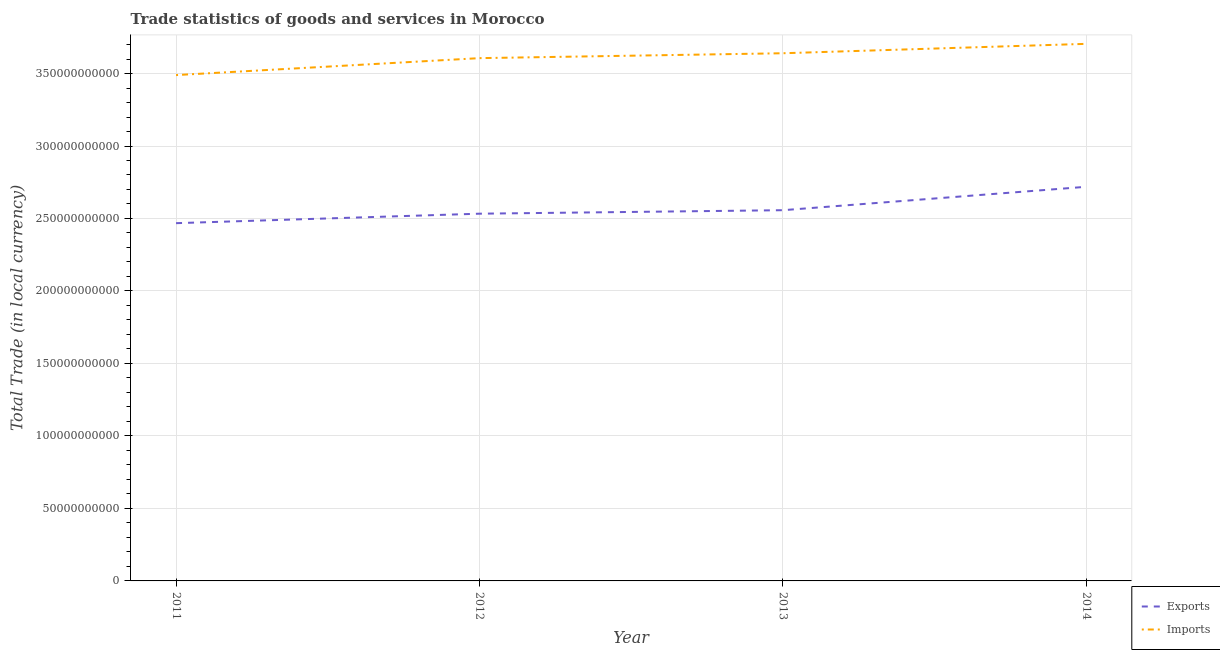How many different coloured lines are there?
Your response must be concise. 2. Does the line corresponding to imports of goods and services intersect with the line corresponding to export of goods and services?
Your answer should be very brief. No. What is the export of goods and services in 2014?
Provide a short and direct response. 2.72e+11. Across all years, what is the maximum imports of goods and services?
Your answer should be compact. 3.70e+11. Across all years, what is the minimum imports of goods and services?
Ensure brevity in your answer.  3.49e+11. What is the total export of goods and services in the graph?
Your answer should be very brief. 1.03e+12. What is the difference between the imports of goods and services in 2011 and that in 2012?
Your answer should be compact. -1.17e+1. What is the difference between the imports of goods and services in 2011 and the export of goods and services in 2014?
Make the answer very short. 7.71e+1. What is the average imports of goods and services per year?
Your answer should be very brief. 3.61e+11. In the year 2013, what is the difference between the export of goods and services and imports of goods and services?
Provide a succinct answer. -1.08e+11. What is the ratio of the export of goods and services in 2011 to that in 2014?
Your answer should be compact. 0.91. Is the imports of goods and services in 2012 less than that in 2013?
Your answer should be very brief. Yes. Is the difference between the imports of goods and services in 2012 and 2013 greater than the difference between the export of goods and services in 2012 and 2013?
Provide a short and direct response. No. What is the difference between the highest and the second highest imports of goods and services?
Provide a short and direct response. 6.49e+09. What is the difference between the highest and the lowest imports of goods and services?
Provide a short and direct response. 2.15e+1. Is the imports of goods and services strictly less than the export of goods and services over the years?
Your answer should be very brief. No. How many lines are there?
Provide a succinct answer. 2. Are the values on the major ticks of Y-axis written in scientific E-notation?
Give a very brief answer. No. Does the graph contain any zero values?
Give a very brief answer. No. Does the graph contain grids?
Give a very brief answer. Yes. How many legend labels are there?
Give a very brief answer. 2. What is the title of the graph?
Your answer should be very brief. Trade statistics of goods and services in Morocco. What is the label or title of the X-axis?
Give a very brief answer. Year. What is the label or title of the Y-axis?
Your response must be concise. Total Trade (in local currency). What is the Total Trade (in local currency) in Exports in 2011?
Give a very brief answer. 2.47e+11. What is the Total Trade (in local currency) of Imports in 2011?
Keep it short and to the point. 3.49e+11. What is the Total Trade (in local currency) of Exports in 2012?
Offer a very short reply. 2.53e+11. What is the Total Trade (in local currency) in Imports in 2012?
Ensure brevity in your answer.  3.61e+11. What is the Total Trade (in local currency) of Exports in 2013?
Make the answer very short. 2.56e+11. What is the Total Trade (in local currency) of Imports in 2013?
Provide a succinct answer. 3.64e+11. What is the Total Trade (in local currency) of Exports in 2014?
Your answer should be compact. 2.72e+11. What is the Total Trade (in local currency) in Imports in 2014?
Provide a short and direct response. 3.70e+11. Across all years, what is the maximum Total Trade (in local currency) of Exports?
Offer a very short reply. 2.72e+11. Across all years, what is the maximum Total Trade (in local currency) of Imports?
Provide a short and direct response. 3.70e+11. Across all years, what is the minimum Total Trade (in local currency) in Exports?
Keep it short and to the point. 2.47e+11. Across all years, what is the minimum Total Trade (in local currency) in Imports?
Make the answer very short. 3.49e+11. What is the total Total Trade (in local currency) in Exports in the graph?
Ensure brevity in your answer.  1.03e+12. What is the total Total Trade (in local currency) in Imports in the graph?
Provide a short and direct response. 1.44e+12. What is the difference between the Total Trade (in local currency) in Exports in 2011 and that in 2012?
Your answer should be very brief. -6.55e+09. What is the difference between the Total Trade (in local currency) of Imports in 2011 and that in 2012?
Provide a succinct answer. -1.17e+1. What is the difference between the Total Trade (in local currency) of Exports in 2011 and that in 2013?
Make the answer very short. -8.95e+09. What is the difference between the Total Trade (in local currency) of Imports in 2011 and that in 2013?
Give a very brief answer. -1.51e+1. What is the difference between the Total Trade (in local currency) in Exports in 2011 and that in 2014?
Ensure brevity in your answer.  -2.51e+1. What is the difference between the Total Trade (in local currency) of Imports in 2011 and that in 2014?
Make the answer very short. -2.15e+1. What is the difference between the Total Trade (in local currency) in Exports in 2012 and that in 2013?
Provide a short and direct response. -2.40e+09. What is the difference between the Total Trade (in local currency) of Imports in 2012 and that in 2013?
Give a very brief answer. -3.38e+09. What is the difference between the Total Trade (in local currency) of Exports in 2012 and that in 2014?
Keep it short and to the point. -1.86e+1. What is the difference between the Total Trade (in local currency) in Imports in 2012 and that in 2014?
Make the answer very short. -9.86e+09. What is the difference between the Total Trade (in local currency) in Exports in 2013 and that in 2014?
Offer a terse response. -1.61e+1. What is the difference between the Total Trade (in local currency) of Imports in 2013 and that in 2014?
Make the answer very short. -6.49e+09. What is the difference between the Total Trade (in local currency) of Exports in 2011 and the Total Trade (in local currency) of Imports in 2012?
Keep it short and to the point. -1.14e+11. What is the difference between the Total Trade (in local currency) in Exports in 2011 and the Total Trade (in local currency) in Imports in 2013?
Offer a very short reply. -1.17e+11. What is the difference between the Total Trade (in local currency) in Exports in 2011 and the Total Trade (in local currency) in Imports in 2014?
Give a very brief answer. -1.24e+11. What is the difference between the Total Trade (in local currency) of Exports in 2012 and the Total Trade (in local currency) of Imports in 2013?
Offer a very short reply. -1.11e+11. What is the difference between the Total Trade (in local currency) of Exports in 2012 and the Total Trade (in local currency) of Imports in 2014?
Your answer should be compact. -1.17e+11. What is the difference between the Total Trade (in local currency) of Exports in 2013 and the Total Trade (in local currency) of Imports in 2014?
Ensure brevity in your answer.  -1.15e+11. What is the average Total Trade (in local currency) of Exports per year?
Keep it short and to the point. 2.57e+11. What is the average Total Trade (in local currency) of Imports per year?
Provide a succinct answer. 3.61e+11. In the year 2011, what is the difference between the Total Trade (in local currency) of Exports and Total Trade (in local currency) of Imports?
Ensure brevity in your answer.  -1.02e+11. In the year 2012, what is the difference between the Total Trade (in local currency) of Exports and Total Trade (in local currency) of Imports?
Make the answer very short. -1.07e+11. In the year 2013, what is the difference between the Total Trade (in local currency) in Exports and Total Trade (in local currency) in Imports?
Your answer should be compact. -1.08e+11. In the year 2014, what is the difference between the Total Trade (in local currency) of Exports and Total Trade (in local currency) of Imports?
Your response must be concise. -9.86e+1. What is the ratio of the Total Trade (in local currency) in Exports in 2011 to that in 2012?
Your answer should be very brief. 0.97. What is the ratio of the Total Trade (in local currency) of Imports in 2011 to that in 2012?
Offer a terse response. 0.97. What is the ratio of the Total Trade (in local currency) in Exports in 2011 to that in 2013?
Give a very brief answer. 0.96. What is the ratio of the Total Trade (in local currency) of Imports in 2011 to that in 2013?
Provide a succinct answer. 0.96. What is the ratio of the Total Trade (in local currency) of Exports in 2011 to that in 2014?
Give a very brief answer. 0.91. What is the ratio of the Total Trade (in local currency) in Imports in 2011 to that in 2014?
Keep it short and to the point. 0.94. What is the ratio of the Total Trade (in local currency) in Exports in 2012 to that in 2013?
Provide a short and direct response. 0.99. What is the ratio of the Total Trade (in local currency) in Imports in 2012 to that in 2013?
Offer a very short reply. 0.99. What is the ratio of the Total Trade (in local currency) of Exports in 2012 to that in 2014?
Keep it short and to the point. 0.93. What is the ratio of the Total Trade (in local currency) in Imports in 2012 to that in 2014?
Your answer should be compact. 0.97. What is the ratio of the Total Trade (in local currency) of Exports in 2013 to that in 2014?
Offer a terse response. 0.94. What is the ratio of the Total Trade (in local currency) in Imports in 2013 to that in 2014?
Give a very brief answer. 0.98. What is the difference between the highest and the second highest Total Trade (in local currency) of Exports?
Offer a very short reply. 1.61e+1. What is the difference between the highest and the second highest Total Trade (in local currency) of Imports?
Ensure brevity in your answer.  6.49e+09. What is the difference between the highest and the lowest Total Trade (in local currency) of Exports?
Provide a succinct answer. 2.51e+1. What is the difference between the highest and the lowest Total Trade (in local currency) in Imports?
Your response must be concise. 2.15e+1. 